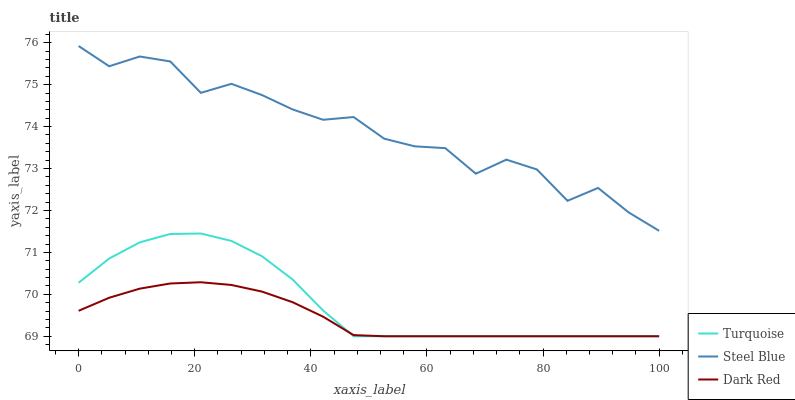Does Dark Red have the minimum area under the curve?
Answer yes or no. Yes. Does Steel Blue have the maximum area under the curve?
Answer yes or no. Yes. Does Turquoise have the minimum area under the curve?
Answer yes or no. No. Does Turquoise have the maximum area under the curve?
Answer yes or no. No. Is Dark Red the smoothest?
Answer yes or no. Yes. Is Steel Blue the roughest?
Answer yes or no. Yes. Is Turquoise the smoothest?
Answer yes or no. No. Is Turquoise the roughest?
Answer yes or no. No. Does Dark Red have the lowest value?
Answer yes or no. Yes. Does Steel Blue have the lowest value?
Answer yes or no. No. Does Steel Blue have the highest value?
Answer yes or no. Yes. Does Turquoise have the highest value?
Answer yes or no. No. Is Turquoise less than Steel Blue?
Answer yes or no. Yes. Is Steel Blue greater than Dark Red?
Answer yes or no. Yes. Does Dark Red intersect Turquoise?
Answer yes or no. Yes. Is Dark Red less than Turquoise?
Answer yes or no. No. Is Dark Red greater than Turquoise?
Answer yes or no. No. Does Turquoise intersect Steel Blue?
Answer yes or no. No. 